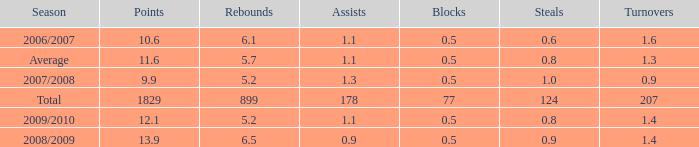How many blocks are there when the rebounds are fewer than 5.2? 0.0. 